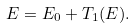<formula> <loc_0><loc_0><loc_500><loc_500>E = E _ { 0 } + T _ { 1 } ( E ) .</formula> 